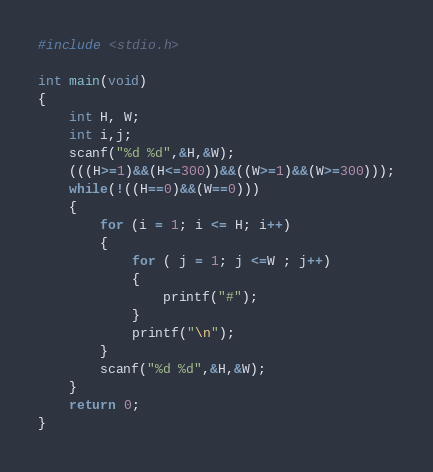Convert code to text. <code><loc_0><loc_0><loc_500><loc_500><_C_>#include <stdio.h>

int main(void)
{
	int H, W;
	int i,j;
    scanf("%d %d",&H,&W);
    (((H>=1)&&(H<=300))&&((W>=1)&&(W>=300)));
    while(!((H==0)&&(W==0)))
	{
		for (i = 1; i <= H; i++)
		{
			for ( j = 1; j <=W ; j++)
			{
				printf("#");
			}
			printf("\n");
		}
		scanf("%d %d",&H,&W);
	}	
	return 0;
}</code> 